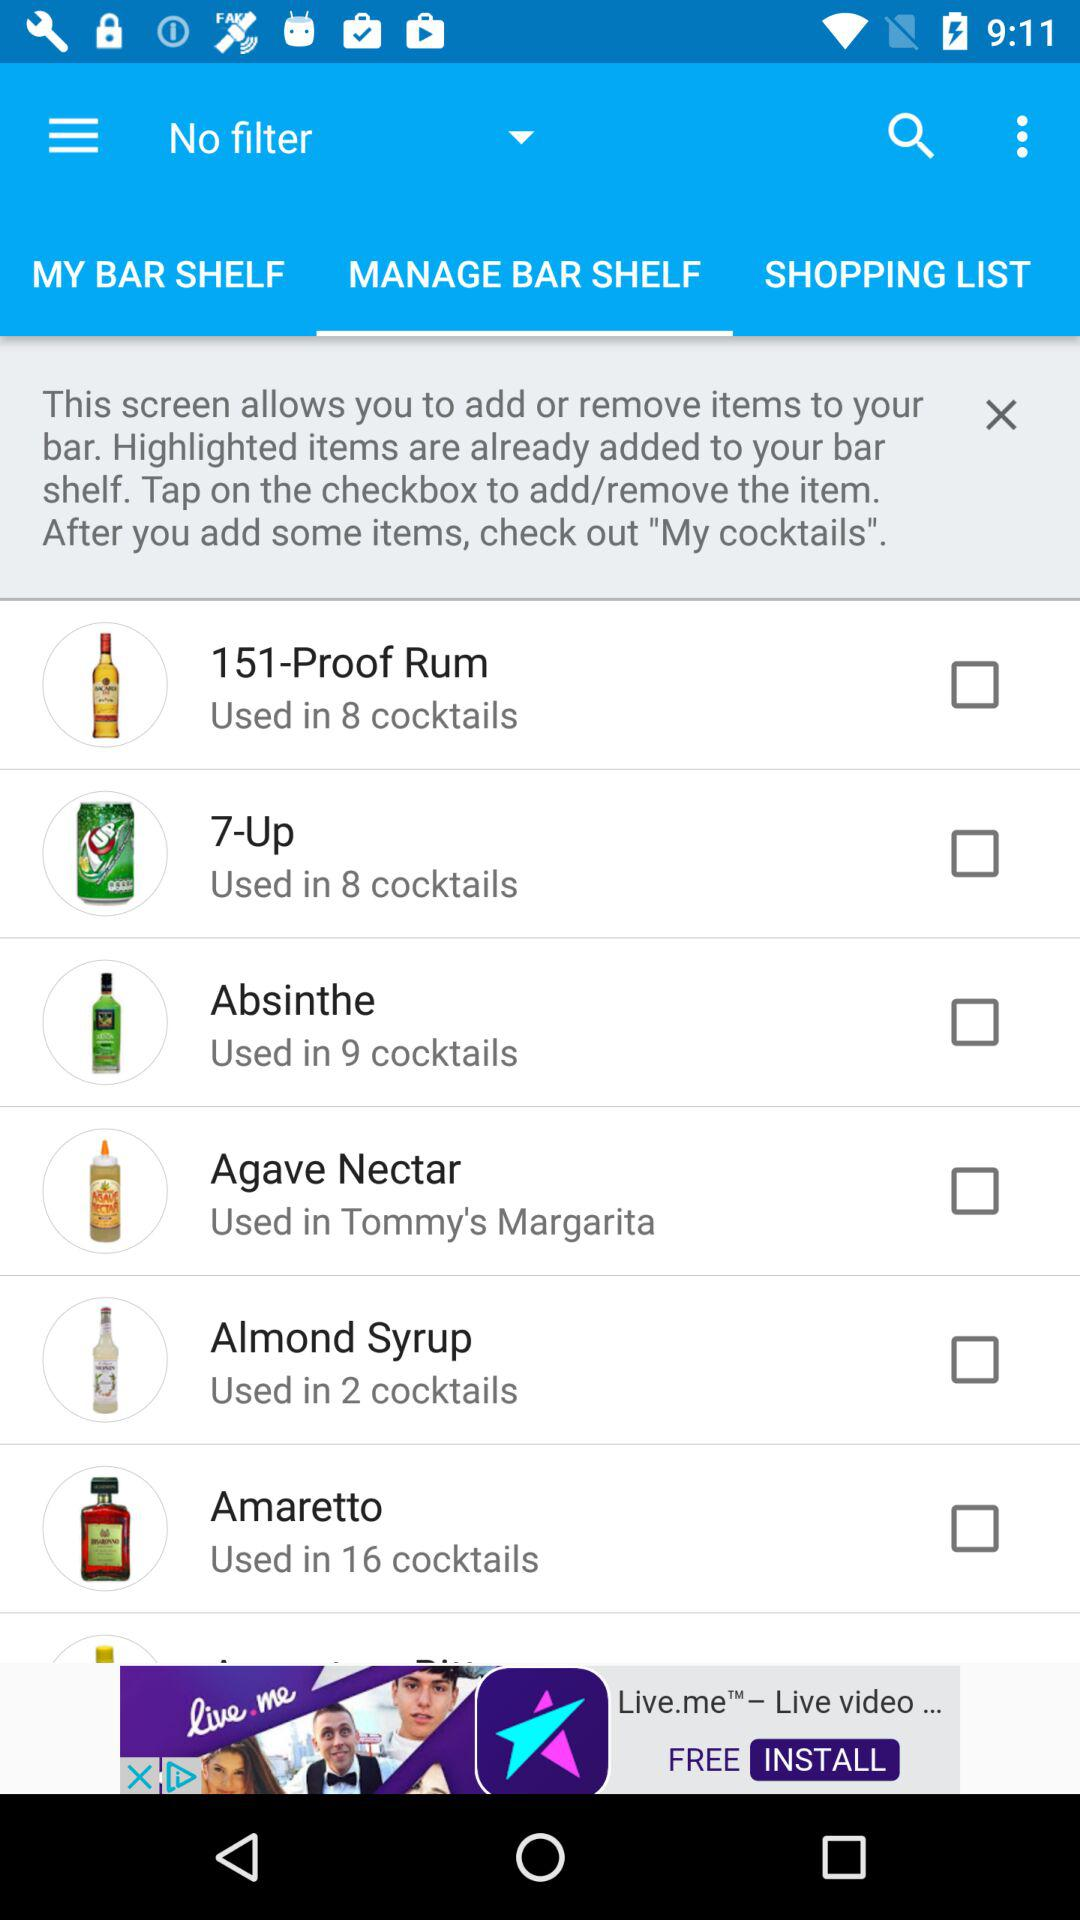In how many cocktails are "151-Proof Rum" used? It is used in 8 cocktails. 